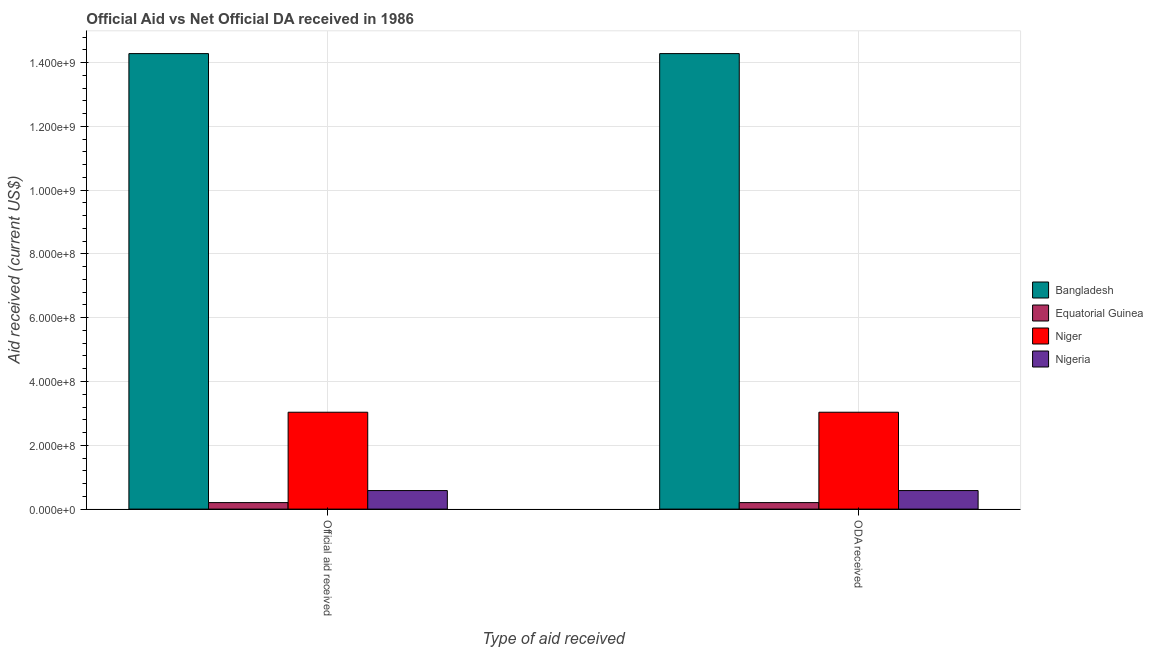How many groups of bars are there?
Provide a succinct answer. 2. Are the number of bars per tick equal to the number of legend labels?
Your answer should be compact. Yes. Are the number of bars on each tick of the X-axis equal?
Your response must be concise. Yes. What is the label of the 2nd group of bars from the left?
Keep it short and to the point. ODA received. What is the oda received in Niger?
Your response must be concise. 3.04e+08. Across all countries, what is the maximum official aid received?
Offer a terse response. 1.43e+09. Across all countries, what is the minimum official aid received?
Your answer should be very brief. 2.04e+07. In which country was the official aid received maximum?
Your answer should be compact. Bangladesh. In which country was the official aid received minimum?
Ensure brevity in your answer.  Equatorial Guinea. What is the total oda received in the graph?
Provide a succinct answer. 1.81e+09. What is the difference between the oda received in Niger and that in Nigeria?
Your answer should be very brief. 2.46e+08. What is the difference between the oda received in Equatorial Guinea and the official aid received in Bangladesh?
Make the answer very short. -1.41e+09. What is the average oda received per country?
Your response must be concise. 4.53e+08. What is the ratio of the official aid received in Bangladesh to that in Niger?
Keep it short and to the point. 4.7. What does the 4th bar from the left in Official aid received represents?
Provide a short and direct response. Nigeria. What does the 3rd bar from the right in ODA received represents?
Provide a succinct answer. Equatorial Guinea. How many countries are there in the graph?
Make the answer very short. 4. Are the values on the major ticks of Y-axis written in scientific E-notation?
Ensure brevity in your answer.  Yes. Does the graph contain any zero values?
Your answer should be compact. No. Where does the legend appear in the graph?
Make the answer very short. Center right. How are the legend labels stacked?
Your response must be concise. Vertical. What is the title of the graph?
Give a very brief answer. Official Aid vs Net Official DA received in 1986 . What is the label or title of the X-axis?
Your answer should be very brief. Type of aid received. What is the label or title of the Y-axis?
Give a very brief answer. Aid received (current US$). What is the Aid received (current US$) of Bangladesh in Official aid received?
Your answer should be compact. 1.43e+09. What is the Aid received (current US$) of Equatorial Guinea in Official aid received?
Make the answer very short. 2.04e+07. What is the Aid received (current US$) in Niger in Official aid received?
Offer a terse response. 3.04e+08. What is the Aid received (current US$) in Nigeria in Official aid received?
Keep it short and to the point. 5.81e+07. What is the Aid received (current US$) of Bangladesh in ODA received?
Your response must be concise. 1.43e+09. What is the Aid received (current US$) of Equatorial Guinea in ODA received?
Your response must be concise. 2.04e+07. What is the Aid received (current US$) of Niger in ODA received?
Your answer should be compact. 3.04e+08. What is the Aid received (current US$) in Nigeria in ODA received?
Make the answer very short. 5.81e+07. Across all Type of aid received, what is the maximum Aid received (current US$) of Bangladesh?
Give a very brief answer. 1.43e+09. Across all Type of aid received, what is the maximum Aid received (current US$) of Equatorial Guinea?
Provide a short and direct response. 2.04e+07. Across all Type of aid received, what is the maximum Aid received (current US$) of Niger?
Make the answer very short. 3.04e+08. Across all Type of aid received, what is the maximum Aid received (current US$) of Nigeria?
Make the answer very short. 5.81e+07. Across all Type of aid received, what is the minimum Aid received (current US$) in Bangladesh?
Your answer should be compact. 1.43e+09. Across all Type of aid received, what is the minimum Aid received (current US$) of Equatorial Guinea?
Ensure brevity in your answer.  2.04e+07. Across all Type of aid received, what is the minimum Aid received (current US$) of Niger?
Make the answer very short. 3.04e+08. Across all Type of aid received, what is the minimum Aid received (current US$) of Nigeria?
Your answer should be compact. 5.81e+07. What is the total Aid received (current US$) of Bangladesh in the graph?
Provide a succinct answer. 2.86e+09. What is the total Aid received (current US$) in Equatorial Guinea in the graph?
Provide a succinct answer. 4.08e+07. What is the total Aid received (current US$) in Niger in the graph?
Offer a very short reply. 6.07e+08. What is the total Aid received (current US$) in Nigeria in the graph?
Offer a terse response. 1.16e+08. What is the difference between the Aid received (current US$) in Equatorial Guinea in Official aid received and that in ODA received?
Offer a terse response. 0. What is the difference between the Aid received (current US$) in Niger in Official aid received and that in ODA received?
Give a very brief answer. 0. What is the difference between the Aid received (current US$) in Nigeria in Official aid received and that in ODA received?
Offer a very short reply. 0. What is the difference between the Aid received (current US$) of Bangladesh in Official aid received and the Aid received (current US$) of Equatorial Guinea in ODA received?
Make the answer very short. 1.41e+09. What is the difference between the Aid received (current US$) of Bangladesh in Official aid received and the Aid received (current US$) of Niger in ODA received?
Make the answer very short. 1.12e+09. What is the difference between the Aid received (current US$) of Bangladesh in Official aid received and the Aid received (current US$) of Nigeria in ODA received?
Your answer should be very brief. 1.37e+09. What is the difference between the Aid received (current US$) in Equatorial Guinea in Official aid received and the Aid received (current US$) in Niger in ODA received?
Offer a very short reply. -2.83e+08. What is the difference between the Aid received (current US$) of Equatorial Guinea in Official aid received and the Aid received (current US$) of Nigeria in ODA received?
Your answer should be compact. -3.77e+07. What is the difference between the Aid received (current US$) of Niger in Official aid received and the Aid received (current US$) of Nigeria in ODA received?
Provide a short and direct response. 2.46e+08. What is the average Aid received (current US$) in Bangladesh per Type of aid received?
Offer a terse response. 1.43e+09. What is the average Aid received (current US$) in Equatorial Guinea per Type of aid received?
Offer a very short reply. 2.04e+07. What is the average Aid received (current US$) in Niger per Type of aid received?
Offer a very short reply. 3.04e+08. What is the average Aid received (current US$) in Nigeria per Type of aid received?
Give a very brief answer. 5.81e+07. What is the difference between the Aid received (current US$) in Bangladesh and Aid received (current US$) in Equatorial Guinea in Official aid received?
Make the answer very short. 1.41e+09. What is the difference between the Aid received (current US$) of Bangladesh and Aid received (current US$) of Niger in Official aid received?
Your answer should be compact. 1.12e+09. What is the difference between the Aid received (current US$) in Bangladesh and Aid received (current US$) in Nigeria in Official aid received?
Give a very brief answer. 1.37e+09. What is the difference between the Aid received (current US$) in Equatorial Guinea and Aid received (current US$) in Niger in Official aid received?
Offer a terse response. -2.83e+08. What is the difference between the Aid received (current US$) in Equatorial Guinea and Aid received (current US$) in Nigeria in Official aid received?
Offer a very short reply. -3.77e+07. What is the difference between the Aid received (current US$) of Niger and Aid received (current US$) of Nigeria in Official aid received?
Make the answer very short. 2.46e+08. What is the difference between the Aid received (current US$) of Bangladesh and Aid received (current US$) of Equatorial Guinea in ODA received?
Your answer should be very brief. 1.41e+09. What is the difference between the Aid received (current US$) in Bangladesh and Aid received (current US$) in Niger in ODA received?
Your response must be concise. 1.12e+09. What is the difference between the Aid received (current US$) in Bangladesh and Aid received (current US$) in Nigeria in ODA received?
Offer a terse response. 1.37e+09. What is the difference between the Aid received (current US$) in Equatorial Guinea and Aid received (current US$) in Niger in ODA received?
Keep it short and to the point. -2.83e+08. What is the difference between the Aid received (current US$) of Equatorial Guinea and Aid received (current US$) of Nigeria in ODA received?
Ensure brevity in your answer.  -3.77e+07. What is the difference between the Aid received (current US$) of Niger and Aid received (current US$) of Nigeria in ODA received?
Keep it short and to the point. 2.46e+08. What is the ratio of the Aid received (current US$) in Niger in Official aid received to that in ODA received?
Your response must be concise. 1. What is the ratio of the Aid received (current US$) of Nigeria in Official aid received to that in ODA received?
Make the answer very short. 1. What is the difference between the highest and the second highest Aid received (current US$) of Bangladesh?
Offer a terse response. 0. What is the difference between the highest and the lowest Aid received (current US$) in Nigeria?
Give a very brief answer. 0. 